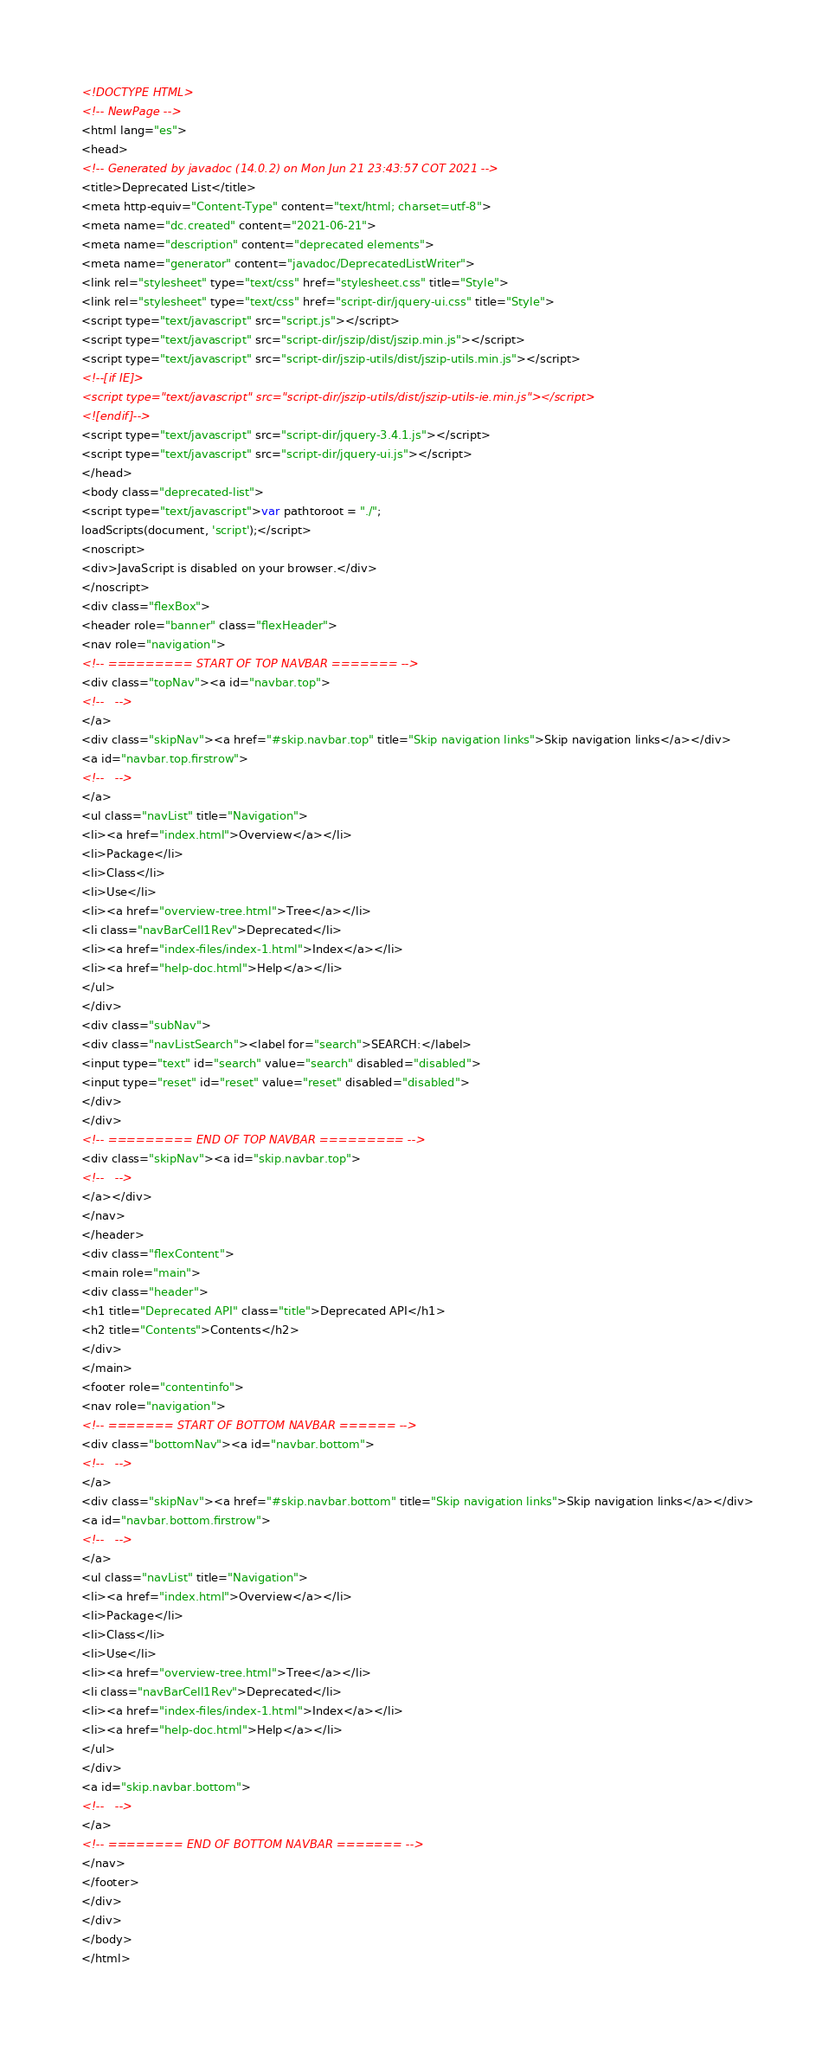Convert code to text. <code><loc_0><loc_0><loc_500><loc_500><_HTML_><!DOCTYPE HTML>
<!-- NewPage -->
<html lang="es">
<head>
<!-- Generated by javadoc (14.0.2) on Mon Jun 21 23:43:57 COT 2021 -->
<title>Deprecated List</title>
<meta http-equiv="Content-Type" content="text/html; charset=utf-8">
<meta name="dc.created" content="2021-06-21">
<meta name="description" content="deprecated elements">
<meta name="generator" content="javadoc/DeprecatedListWriter">
<link rel="stylesheet" type="text/css" href="stylesheet.css" title="Style">
<link rel="stylesheet" type="text/css" href="script-dir/jquery-ui.css" title="Style">
<script type="text/javascript" src="script.js"></script>
<script type="text/javascript" src="script-dir/jszip/dist/jszip.min.js"></script>
<script type="text/javascript" src="script-dir/jszip-utils/dist/jszip-utils.min.js"></script>
<!--[if IE]>
<script type="text/javascript" src="script-dir/jszip-utils/dist/jszip-utils-ie.min.js"></script>
<![endif]-->
<script type="text/javascript" src="script-dir/jquery-3.4.1.js"></script>
<script type="text/javascript" src="script-dir/jquery-ui.js"></script>
</head>
<body class="deprecated-list">
<script type="text/javascript">var pathtoroot = "./";
loadScripts(document, 'script');</script>
<noscript>
<div>JavaScript is disabled on your browser.</div>
</noscript>
<div class="flexBox">
<header role="banner" class="flexHeader">
<nav role="navigation">
<!-- ========= START OF TOP NAVBAR ======= -->
<div class="topNav"><a id="navbar.top">
<!--   -->
</a>
<div class="skipNav"><a href="#skip.navbar.top" title="Skip navigation links">Skip navigation links</a></div>
<a id="navbar.top.firstrow">
<!--   -->
</a>
<ul class="navList" title="Navigation">
<li><a href="index.html">Overview</a></li>
<li>Package</li>
<li>Class</li>
<li>Use</li>
<li><a href="overview-tree.html">Tree</a></li>
<li class="navBarCell1Rev">Deprecated</li>
<li><a href="index-files/index-1.html">Index</a></li>
<li><a href="help-doc.html">Help</a></li>
</ul>
</div>
<div class="subNav">
<div class="navListSearch"><label for="search">SEARCH:</label>
<input type="text" id="search" value="search" disabled="disabled">
<input type="reset" id="reset" value="reset" disabled="disabled">
</div>
</div>
<!-- ========= END OF TOP NAVBAR ========= -->
<div class="skipNav"><a id="skip.navbar.top">
<!--   -->
</a></div>
</nav>
</header>
<div class="flexContent">
<main role="main">
<div class="header">
<h1 title="Deprecated API" class="title">Deprecated API</h1>
<h2 title="Contents">Contents</h2>
</div>
</main>
<footer role="contentinfo">
<nav role="navigation">
<!-- ======= START OF BOTTOM NAVBAR ====== -->
<div class="bottomNav"><a id="navbar.bottom">
<!--   -->
</a>
<div class="skipNav"><a href="#skip.navbar.bottom" title="Skip navigation links">Skip navigation links</a></div>
<a id="navbar.bottom.firstrow">
<!--   -->
</a>
<ul class="navList" title="Navigation">
<li><a href="index.html">Overview</a></li>
<li>Package</li>
<li>Class</li>
<li>Use</li>
<li><a href="overview-tree.html">Tree</a></li>
<li class="navBarCell1Rev">Deprecated</li>
<li><a href="index-files/index-1.html">Index</a></li>
<li><a href="help-doc.html">Help</a></li>
</ul>
</div>
<a id="skip.navbar.bottom">
<!--   -->
</a>
<!-- ======== END OF BOTTOM NAVBAR ======= -->
</nav>
</footer>
</div>
</div>
</body>
</html>
</code> 